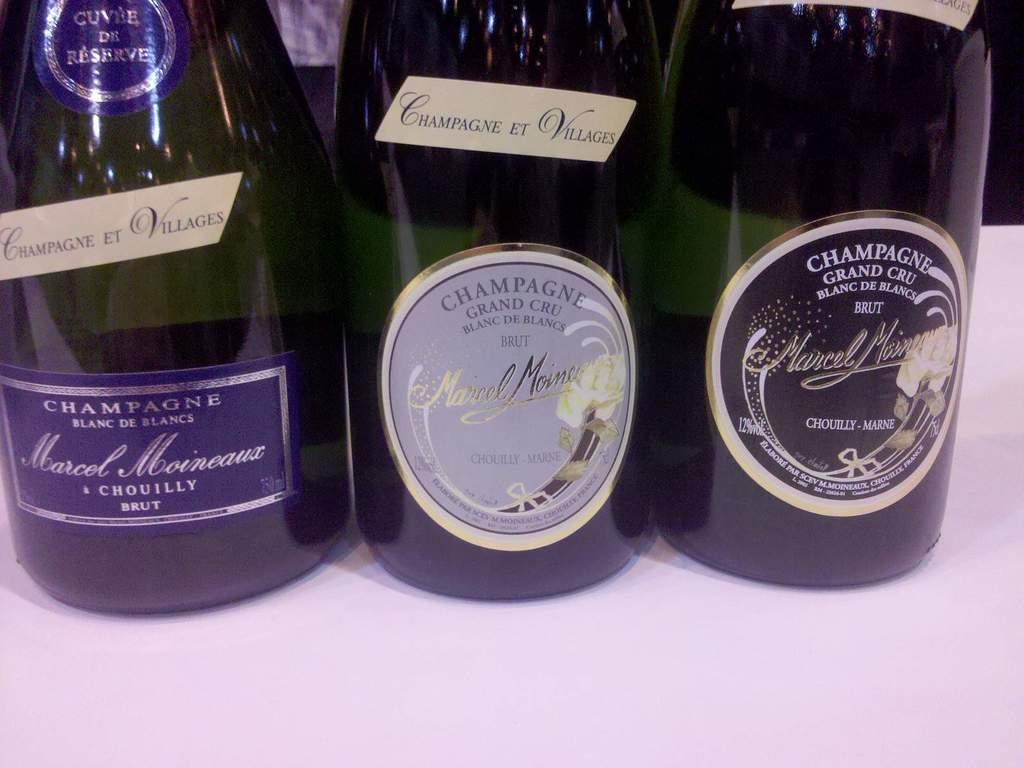<image>
Share a concise interpretation of the image provided. Three bottles of Champagne with the one in the middle being Grand Cru Blanc de Blancs 